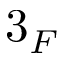Convert formula to latex. <formula><loc_0><loc_0><loc_500><loc_500>3 _ { F }</formula> 